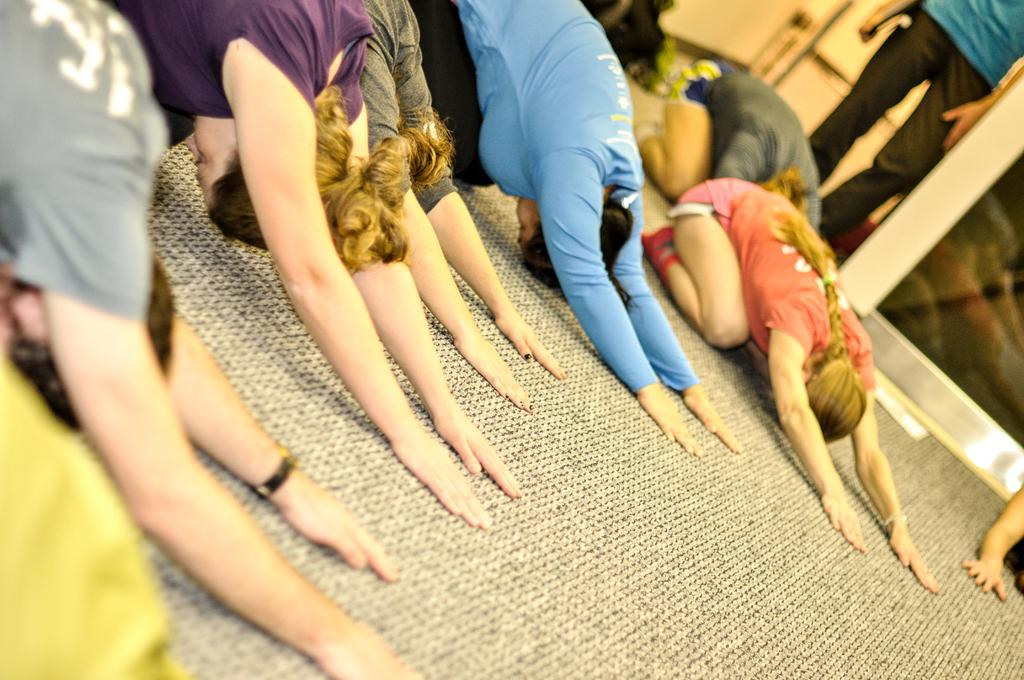What is the main subject of the image? The main subject of the image is a group of girls. Where are the girls located in the image? The girls are sitting on a mat in the image. What are the girls doing in the image? The girls are stretching their hands and doing exercise in the image. What can be seen in the background of the image? There is a glass door in the background of the image. What type of rings can be seen on the girls' fingers in the image? There are no rings visible on the girls' fingers in the image. Can you see any steam coming from the girls' bodies during their exercise? There is no steam present in the image. 